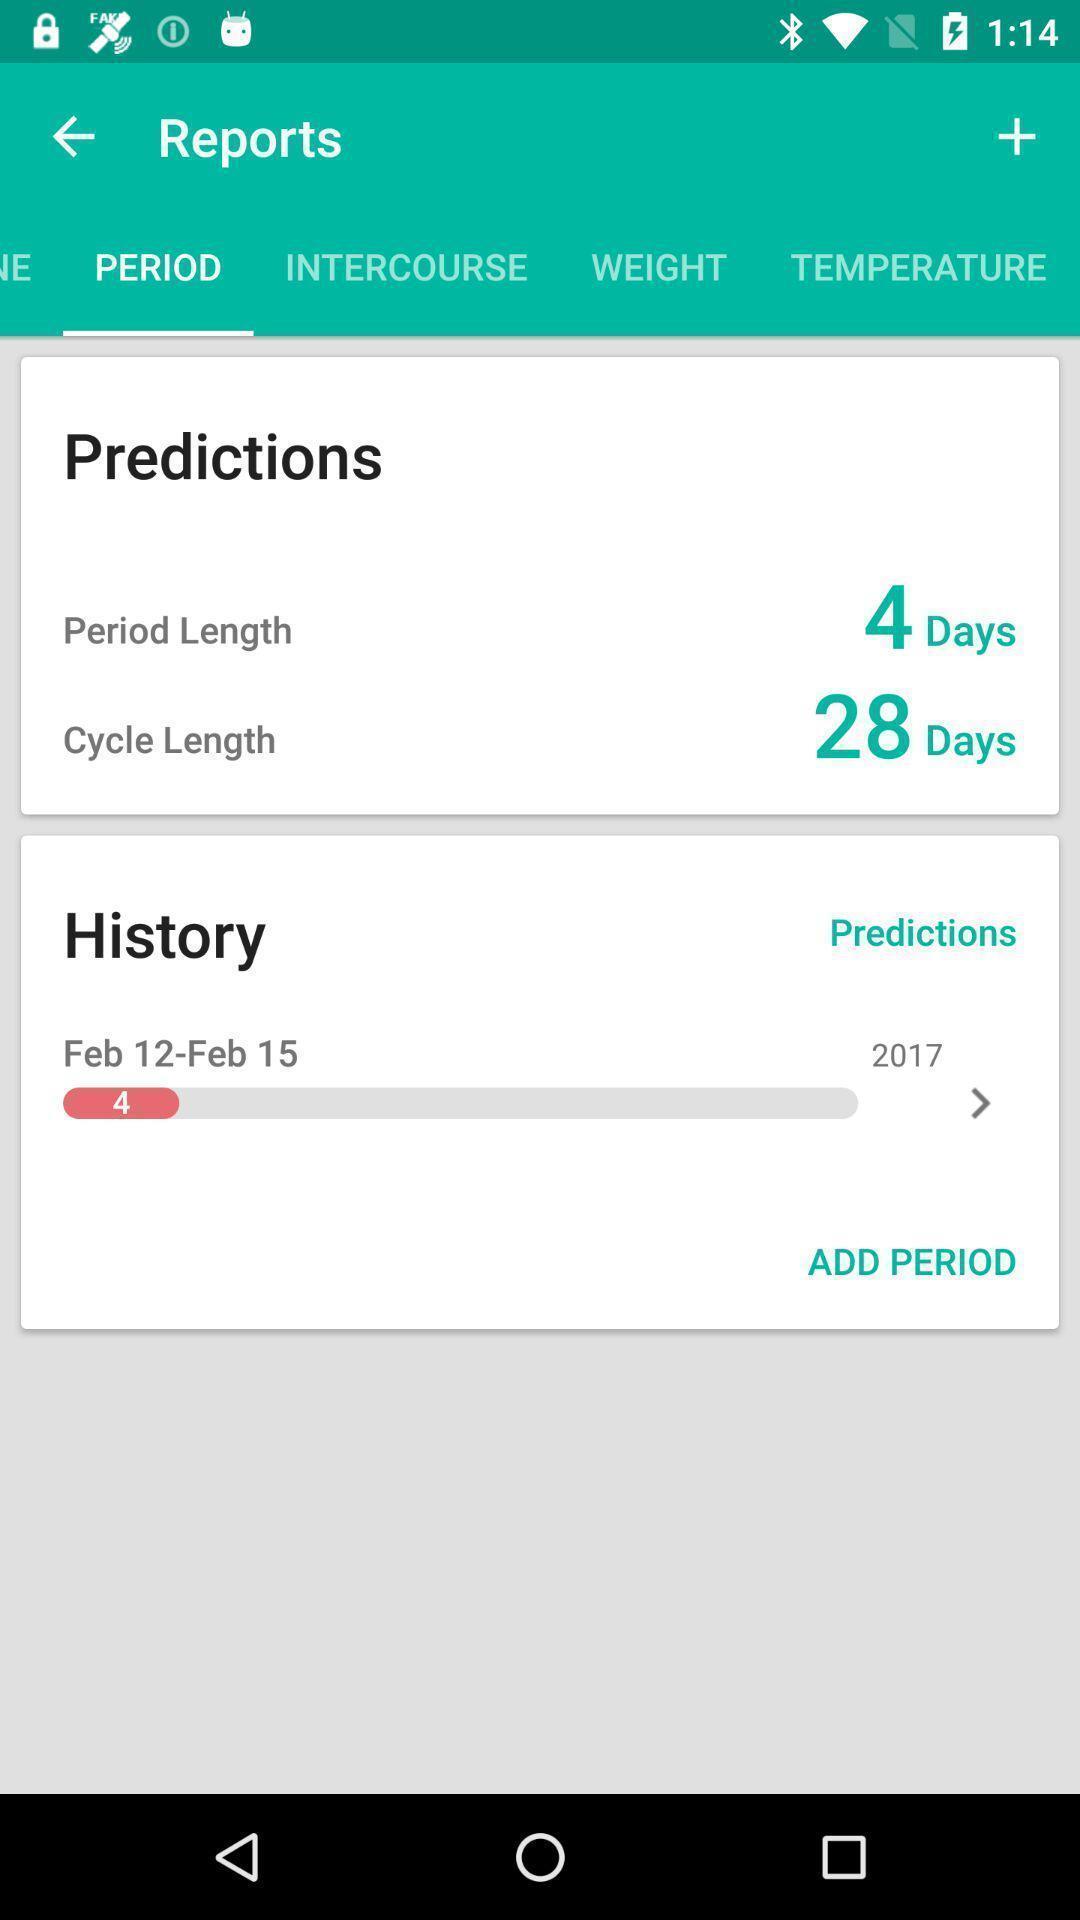Tell me what you see in this picture. Reports page of a period tracker app. 